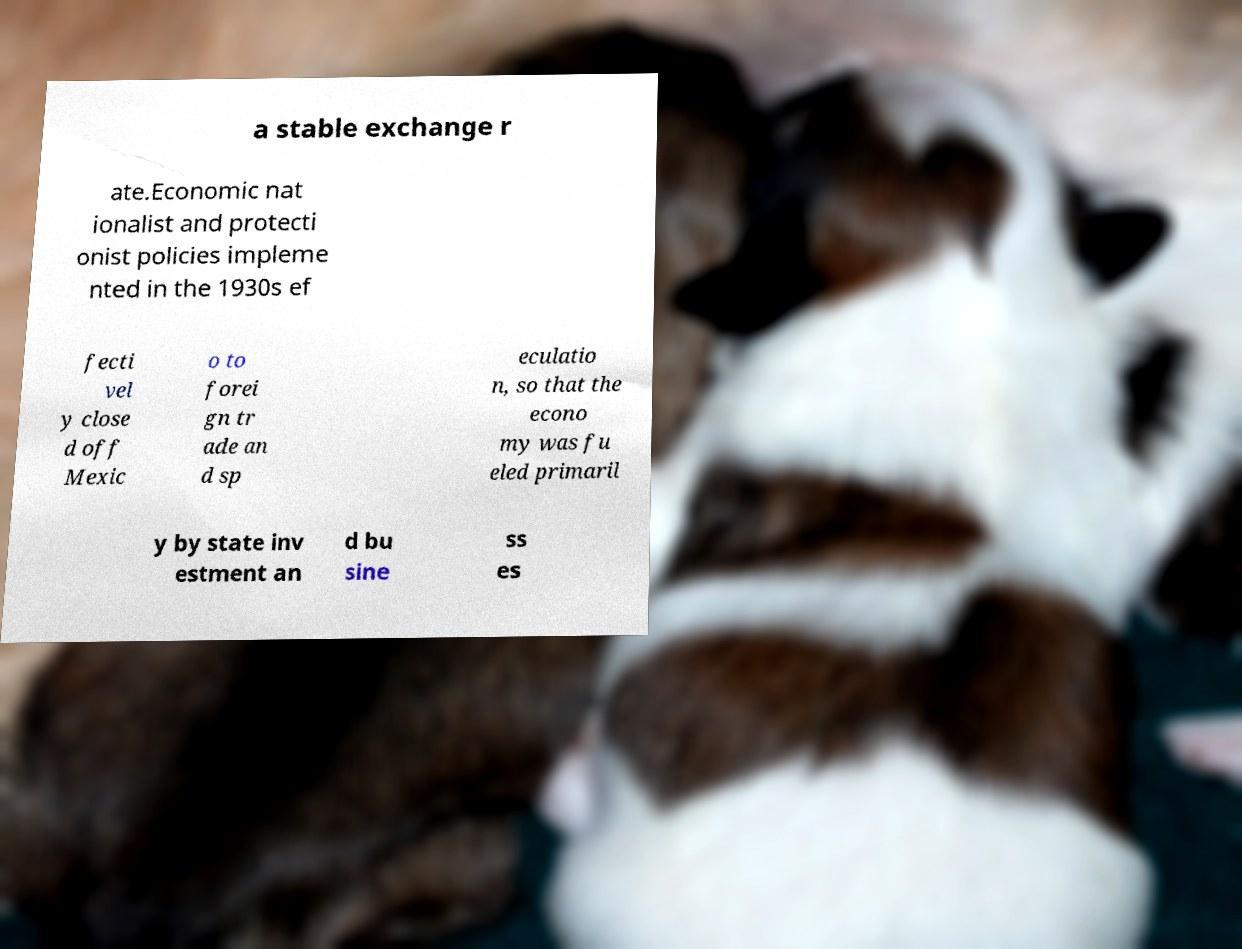What messages or text are displayed in this image? I need them in a readable, typed format. a stable exchange r ate.Economic nat ionalist and protecti onist policies impleme nted in the 1930s ef fecti vel y close d off Mexic o to forei gn tr ade an d sp eculatio n, so that the econo my was fu eled primaril y by state inv estment an d bu sine ss es 